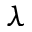<formula> <loc_0><loc_0><loc_500><loc_500>\lambda</formula> 